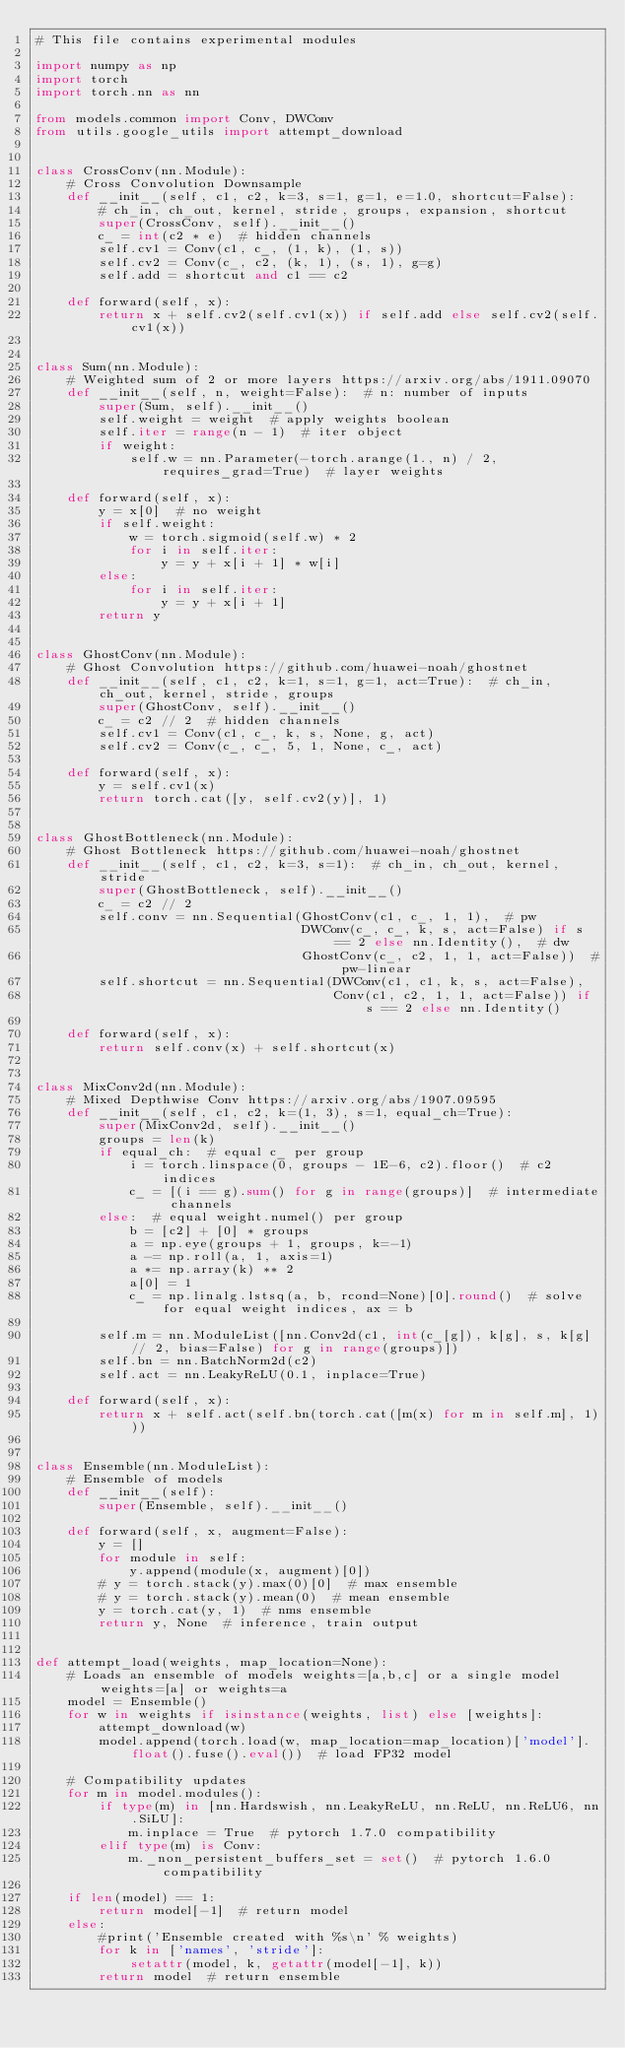Convert code to text. <code><loc_0><loc_0><loc_500><loc_500><_Python_># This file contains experimental modules

import numpy as np
import torch
import torch.nn as nn

from models.common import Conv, DWConv
from utils.google_utils import attempt_download


class CrossConv(nn.Module):
    # Cross Convolution Downsample
    def __init__(self, c1, c2, k=3, s=1, g=1, e=1.0, shortcut=False):
        # ch_in, ch_out, kernel, stride, groups, expansion, shortcut
        super(CrossConv, self).__init__()
        c_ = int(c2 * e)  # hidden channels
        self.cv1 = Conv(c1, c_, (1, k), (1, s))
        self.cv2 = Conv(c_, c2, (k, 1), (s, 1), g=g)
        self.add = shortcut and c1 == c2

    def forward(self, x):
        return x + self.cv2(self.cv1(x)) if self.add else self.cv2(self.cv1(x))


class Sum(nn.Module):
    # Weighted sum of 2 or more layers https://arxiv.org/abs/1911.09070
    def __init__(self, n, weight=False):  # n: number of inputs
        super(Sum, self).__init__()
        self.weight = weight  # apply weights boolean
        self.iter = range(n - 1)  # iter object
        if weight:
            self.w = nn.Parameter(-torch.arange(1., n) / 2, requires_grad=True)  # layer weights

    def forward(self, x):
        y = x[0]  # no weight
        if self.weight:
            w = torch.sigmoid(self.w) * 2
            for i in self.iter:
                y = y + x[i + 1] * w[i]
        else:
            for i in self.iter:
                y = y + x[i + 1]
        return y


class GhostConv(nn.Module):
    # Ghost Convolution https://github.com/huawei-noah/ghostnet
    def __init__(self, c1, c2, k=1, s=1, g=1, act=True):  # ch_in, ch_out, kernel, stride, groups
        super(GhostConv, self).__init__()
        c_ = c2 // 2  # hidden channels
        self.cv1 = Conv(c1, c_, k, s, None, g, act)
        self.cv2 = Conv(c_, c_, 5, 1, None, c_, act)

    def forward(self, x):
        y = self.cv1(x)
        return torch.cat([y, self.cv2(y)], 1)


class GhostBottleneck(nn.Module):
    # Ghost Bottleneck https://github.com/huawei-noah/ghostnet
    def __init__(self, c1, c2, k=3, s=1):  # ch_in, ch_out, kernel, stride
        super(GhostBottleneck, self).__init__()
        c_ = c2 // 2
        self.conv = nn.Sequential(GhostConv(c1, c_, 1, 1),  # pw
                                  DWConv(c_, c_, k, s, act=False) if s == 2 else nn.Identity(),  # dw
                                  GhostConv(c_, c2, 1, 1, act=False))  # pw-linear
        self.shortcut = nn.Sequential(DWConv(c1, c1, k, s, act=False),
                                      Conv(c1, c2, 1, 1, act=False)) if s == 2 else nn.Identity()

    def forward(self, x):
        return self.conv(x) + self.shortcut(x)


class MixConv2d(nn.Module):
    # Mixed Depthwise Conv https://arxiv.org/abs/1907.09595
    def __init__(self, c1, c2, k=(1, 3), s=1, equal_ch=True):
        super(MixConv2d, self).__init__()
        groups = len(k)
        if equal_ch:  # equal c_ per group
            i = torch.linspace(0, groups - 1E-6, c2).floor()  # c2 indices
            c_ = [(i == g).sum() for g in range(groups)]  # intermediate channels
        else:  # equal weight.numel() per group
            b = [c2] + [0] * groups
            a = np.eye(groups + 1, groups, k=-1)
            a -= np.roll(a, 1, axis=1)
            a *= np.array(k) ** 2
            a[0] = 1
            c_ = np.linalg.lstsq(a, b, rcond=None)[0].round()  # solve for equal weight indices, ax = b

        self.m = nn.ModuleList([nn.Conv2d(c1, int(c_[g]), k[g], s, k[g] // 2, bias=False) for g in range(groups)])
        self.bn = nn.BatchNorm2d(c2)
        self.act = nn.LeakyReLU(0.1, inplace=True)

    def forward(self, x):
        return x + self.act(self.bn(torch.cat([m(x) for m in self.m], 1)))


class Ensemble(nn.ModuleList):
    # Ensemble of models
    def __init__(self):
        super(Ensemble, self).__init__()

    def forward(self, x, augment=False):
        y = []
        for module in self:
            y.append(module(x, augment)[0])
        # y = torch.stack(y).max(0)[0]  # max ensemble
        # y = torch.stack(y).mean(0)  # mean ensemble
        y = torch.cat(y, 1)  # nms ensemble
        return y, None  # inference, train output


def attempt_load(weights, map_location=None):
    # Loads an ensemble of models weights=[a,b,c] or a single model weights=[a] or weights=a
    model = Ensemble()
    for w in weights if isinstance(weights, list) else [weights]:
        attempt_download(w)
        model.append(torch.load(w, map_location=map_location)['model'].float().fuse().eval())  # load FP32 model

    # Compatibility updates
    for m in model.modules():
        if type(m) in [nn.Hardswish, nn.LeakyReLU, nn.ReLU, nn.ReLU6, nn.SiLU]:
            m.inplace = True  # pytorch 1.7.0 compatibility
        elif type(m) is Conv:
            m._non_persistent_buffers_set = set()  # pytorch 1.6.0 compatibility

    if len(model) == 1:
        return model[-1]  # return model
    else:
        #print('Ensemble created with %s\n' % weights)
        for k in ['names', 'stride']:
            setattr(model, k, getattr(model[-1], k))
        return model  # return ensemble
</code> 